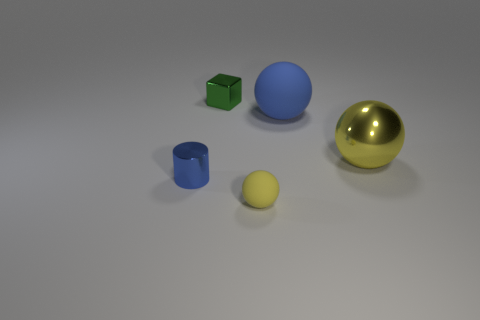How many other things are the same color as the big metallic object?
Your answer should be compact. 1. Is the small sphere made of the same material as the blue thing behind the blue cylinder?
Provide a succinct answer. Yes. Are there more green metal cubes in front of the tiny matte object than small cylinders?
Keep it short and to the point. No. Is there anything else that has the same size as the blue ball?
Your response must be concise. Yes. Does the cube have the same color as the big metallic thing on the right side of the big rubber thing?
Offer a very short reply. No. Are there an equal number of small green shiny blocks that are right of the big blue matte object and shiny balls that are behind the tiny green metal block?
Ensure brevity in your answer.  Yes. What is the yellow sphere left of the big shiny sphere made of?
Offer a very short reply. Rubber. What number of things are small yellow rubber spheres right of the small metal cylinder or tiny yellow shiny cylinders?
Your answer should be compact. 1. How many other objects are the same shape as the big yellow object?
Provide a short and direct response. 2. There is a object that is to the right of the blue ball; does it have the same shape as the tiny green object?
Provide a succinct answer. No. 